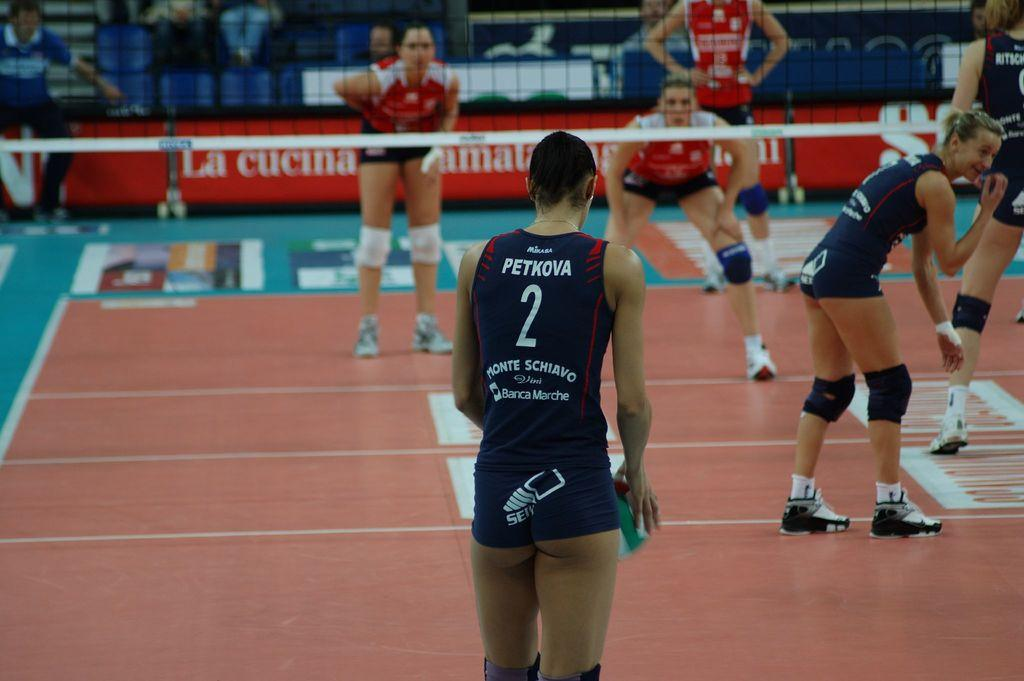What are the girls in the image doing? The girls are playing a sport in the image. Where is the sport being played? The sport is being played in a stadium. What is a key feature of the sport being played? There is a net in the image, which suggests it is a sport that involves a net, such as volleyball or tennis. What can be seen in the background of the image? There is an advertisement board in the background of the image. How many cats are sitting on the crate in the image? There are no cats or crates present in the image. What act are the girls performing in the image? The girls are playing a sport, but we cannot determine a specific act from the image alone. 